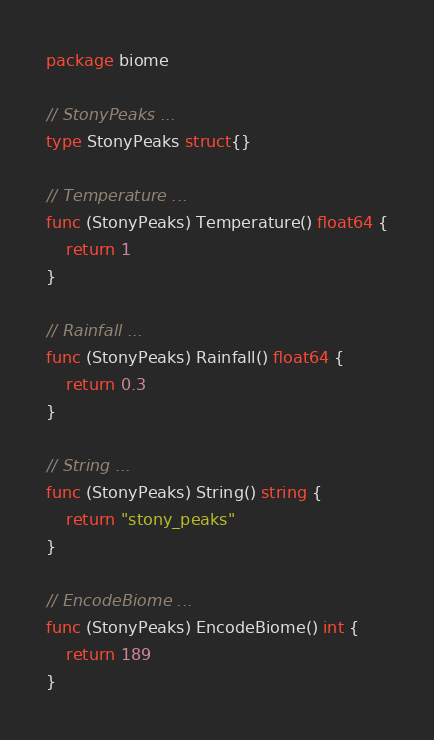Convert code to text. <code><loc_0><loc_0><loc_500><loc_500><_Go_>package biome

// StonyPeaks ...
type StonyPeaks struct{}

// Temperature ...
func (StonyPeaks) Temperature() float64 {
	return 1
}

// Rainfall ...
func (StonyPeaks) Rainfall() float64 {
	return 0.3
}

// String ...
func (StonyPeaks) String() string {
	return "stony_peaks"
}

// EncodeBiome ...
func (StonyPeaks) EncodeBiome() int {
	return 189
}
</code> 